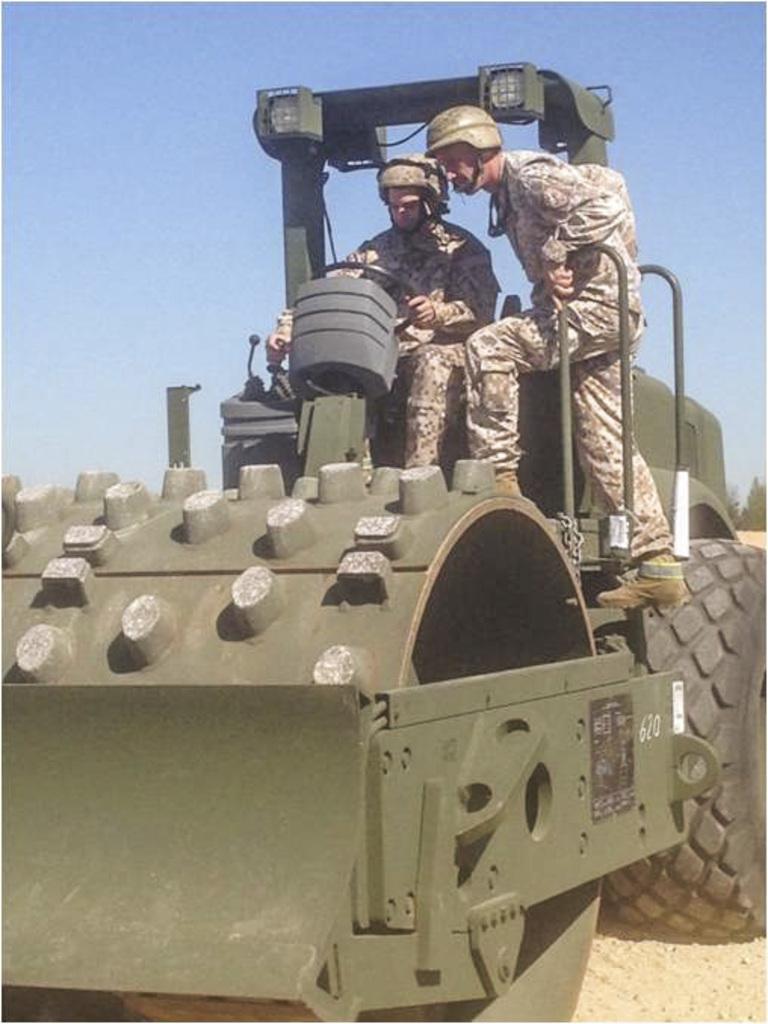Please provide a concise description of this image. Here we can see a person sitting on the seat and riding a vehicle on the road. On the right there is a person standing on the vehicle. In the background there is a sky and on the right there are trees. 